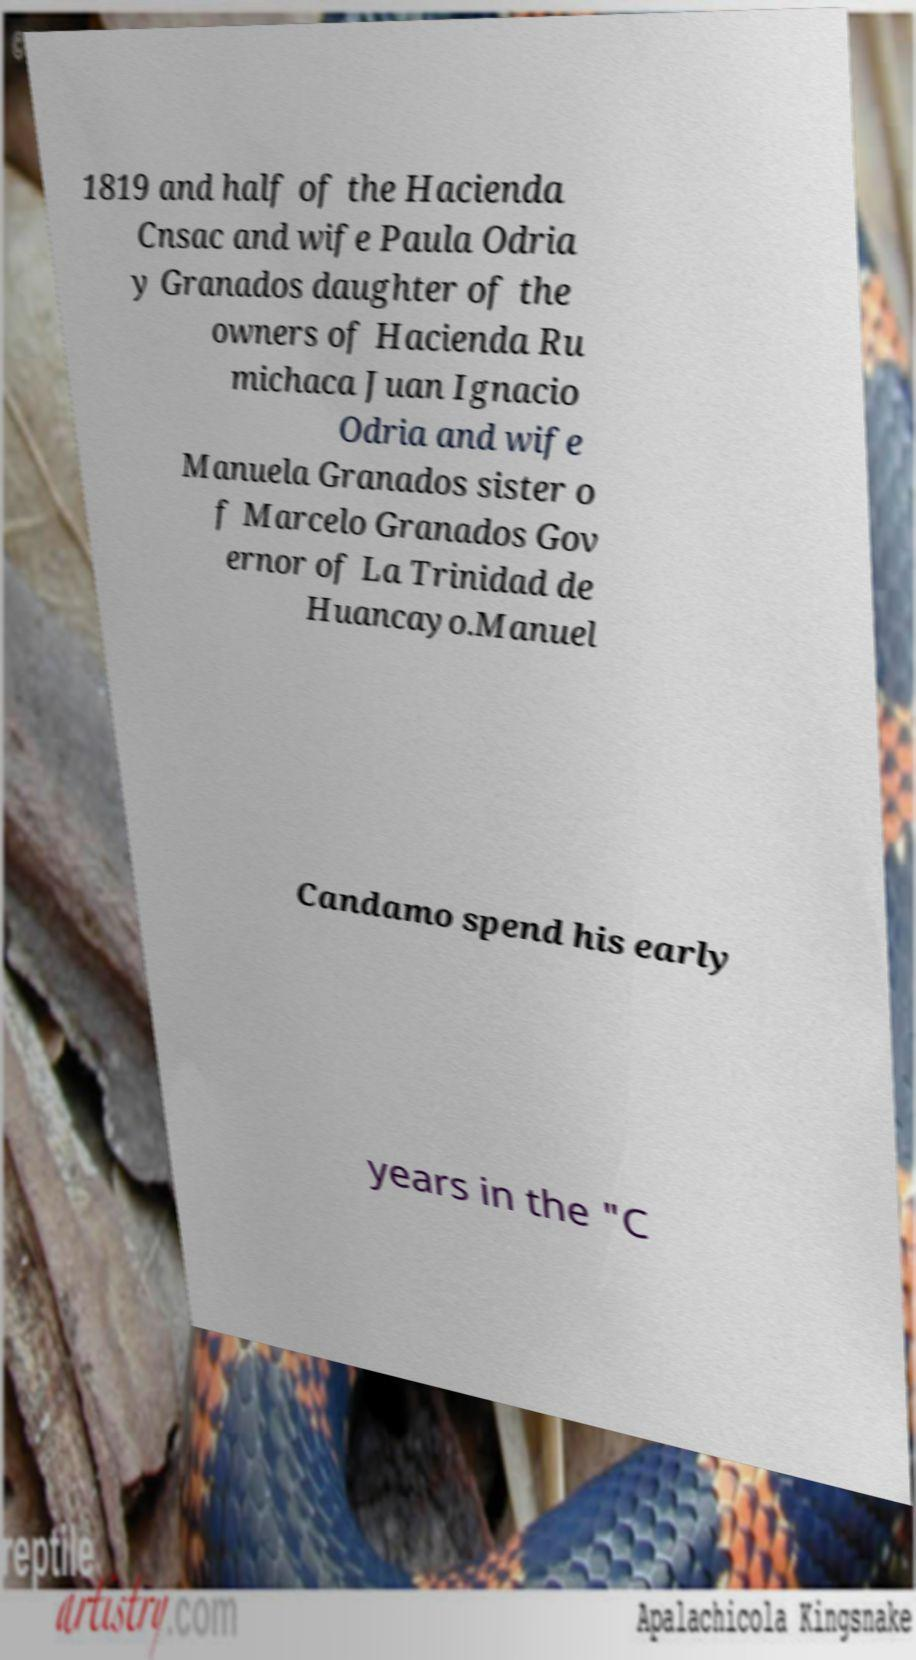Can you read and provide the text displayed in the image?This photo seems to have some interesting text. Can you extract and type it out for me? 1819 and half of the Hacienda Cnsac and wife Paula Odria y Granados daughter of the owners of Hacienda Ru michaca Juan Ignacio Odria and wife Manuela Granados sister o f Marcelo Granados Gov ernor of La Trinidad de Huancayo.Manuel Candamo spend his early years in the "C 